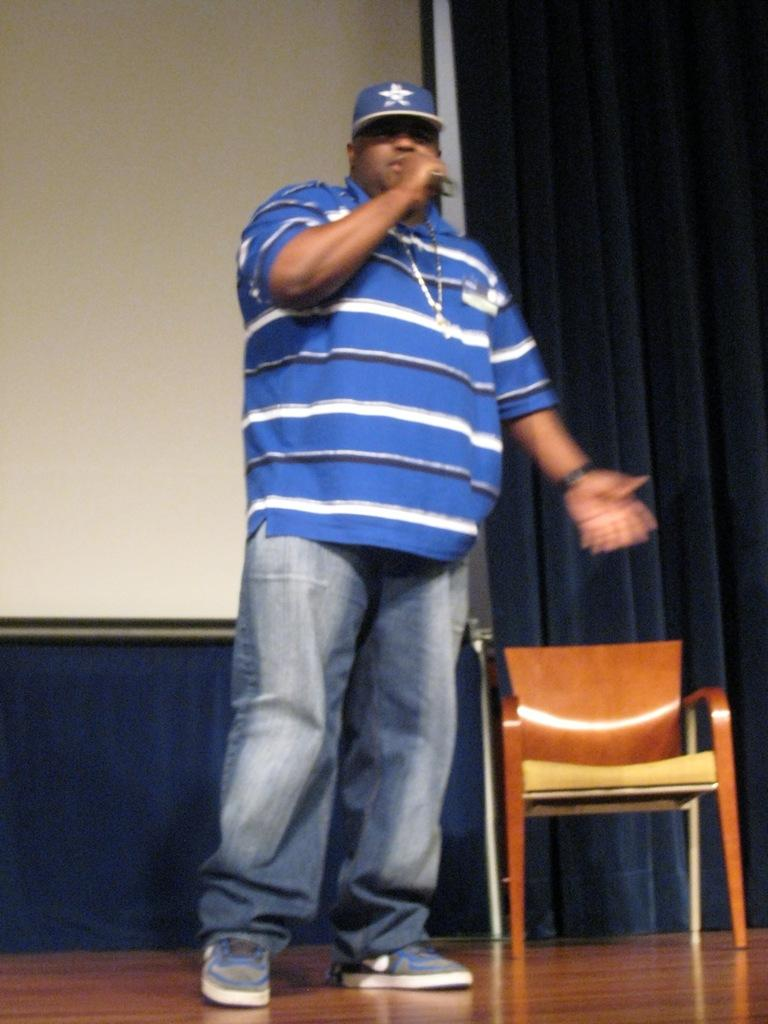What is the main subject of the image? There is a man in the image. What is the man doing in the image? The man is holding an object and explaining something. What can be seen in the background of the image? There is a chair, a projector screen, and a curtain in the image. What type of lock is visible on the projector screen in the image? There is no lock visible on the projector screen in the image; it is a screen used for displaying visual information. 